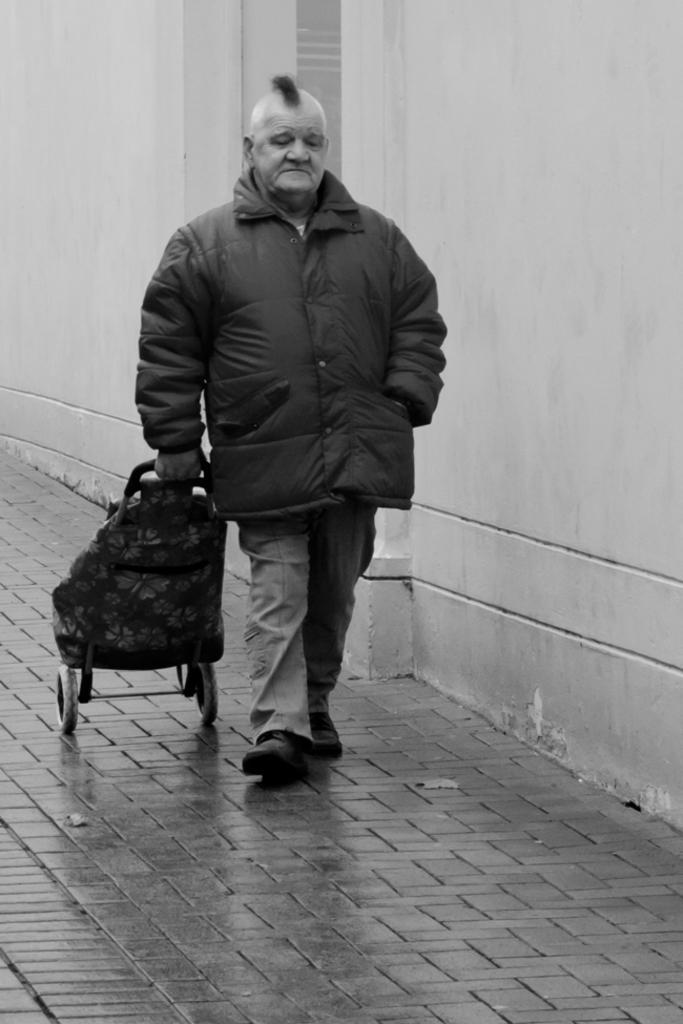In one or two sentences, can you explain what this image depicts? In the image in the center, we can see one person standing and holding wheelchair. In the background there is a wall. 